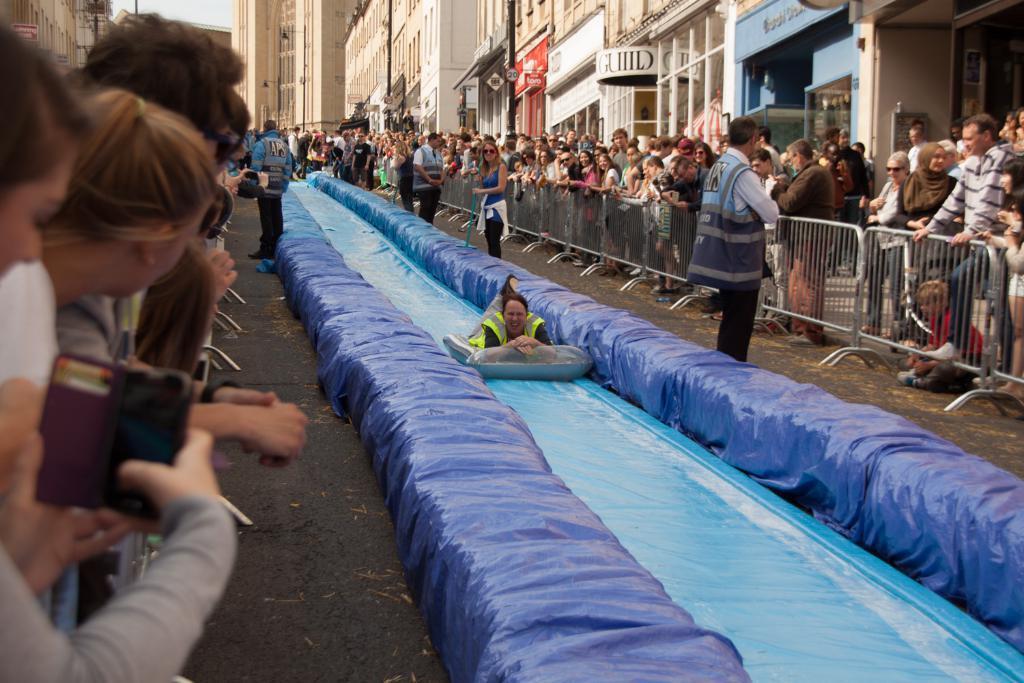Could you give a brief overview of what you see in this image? In this image I can see group of people are standing. Here I can see a woman is sliding on an object. In the background I can see fence, poles and buildings. 